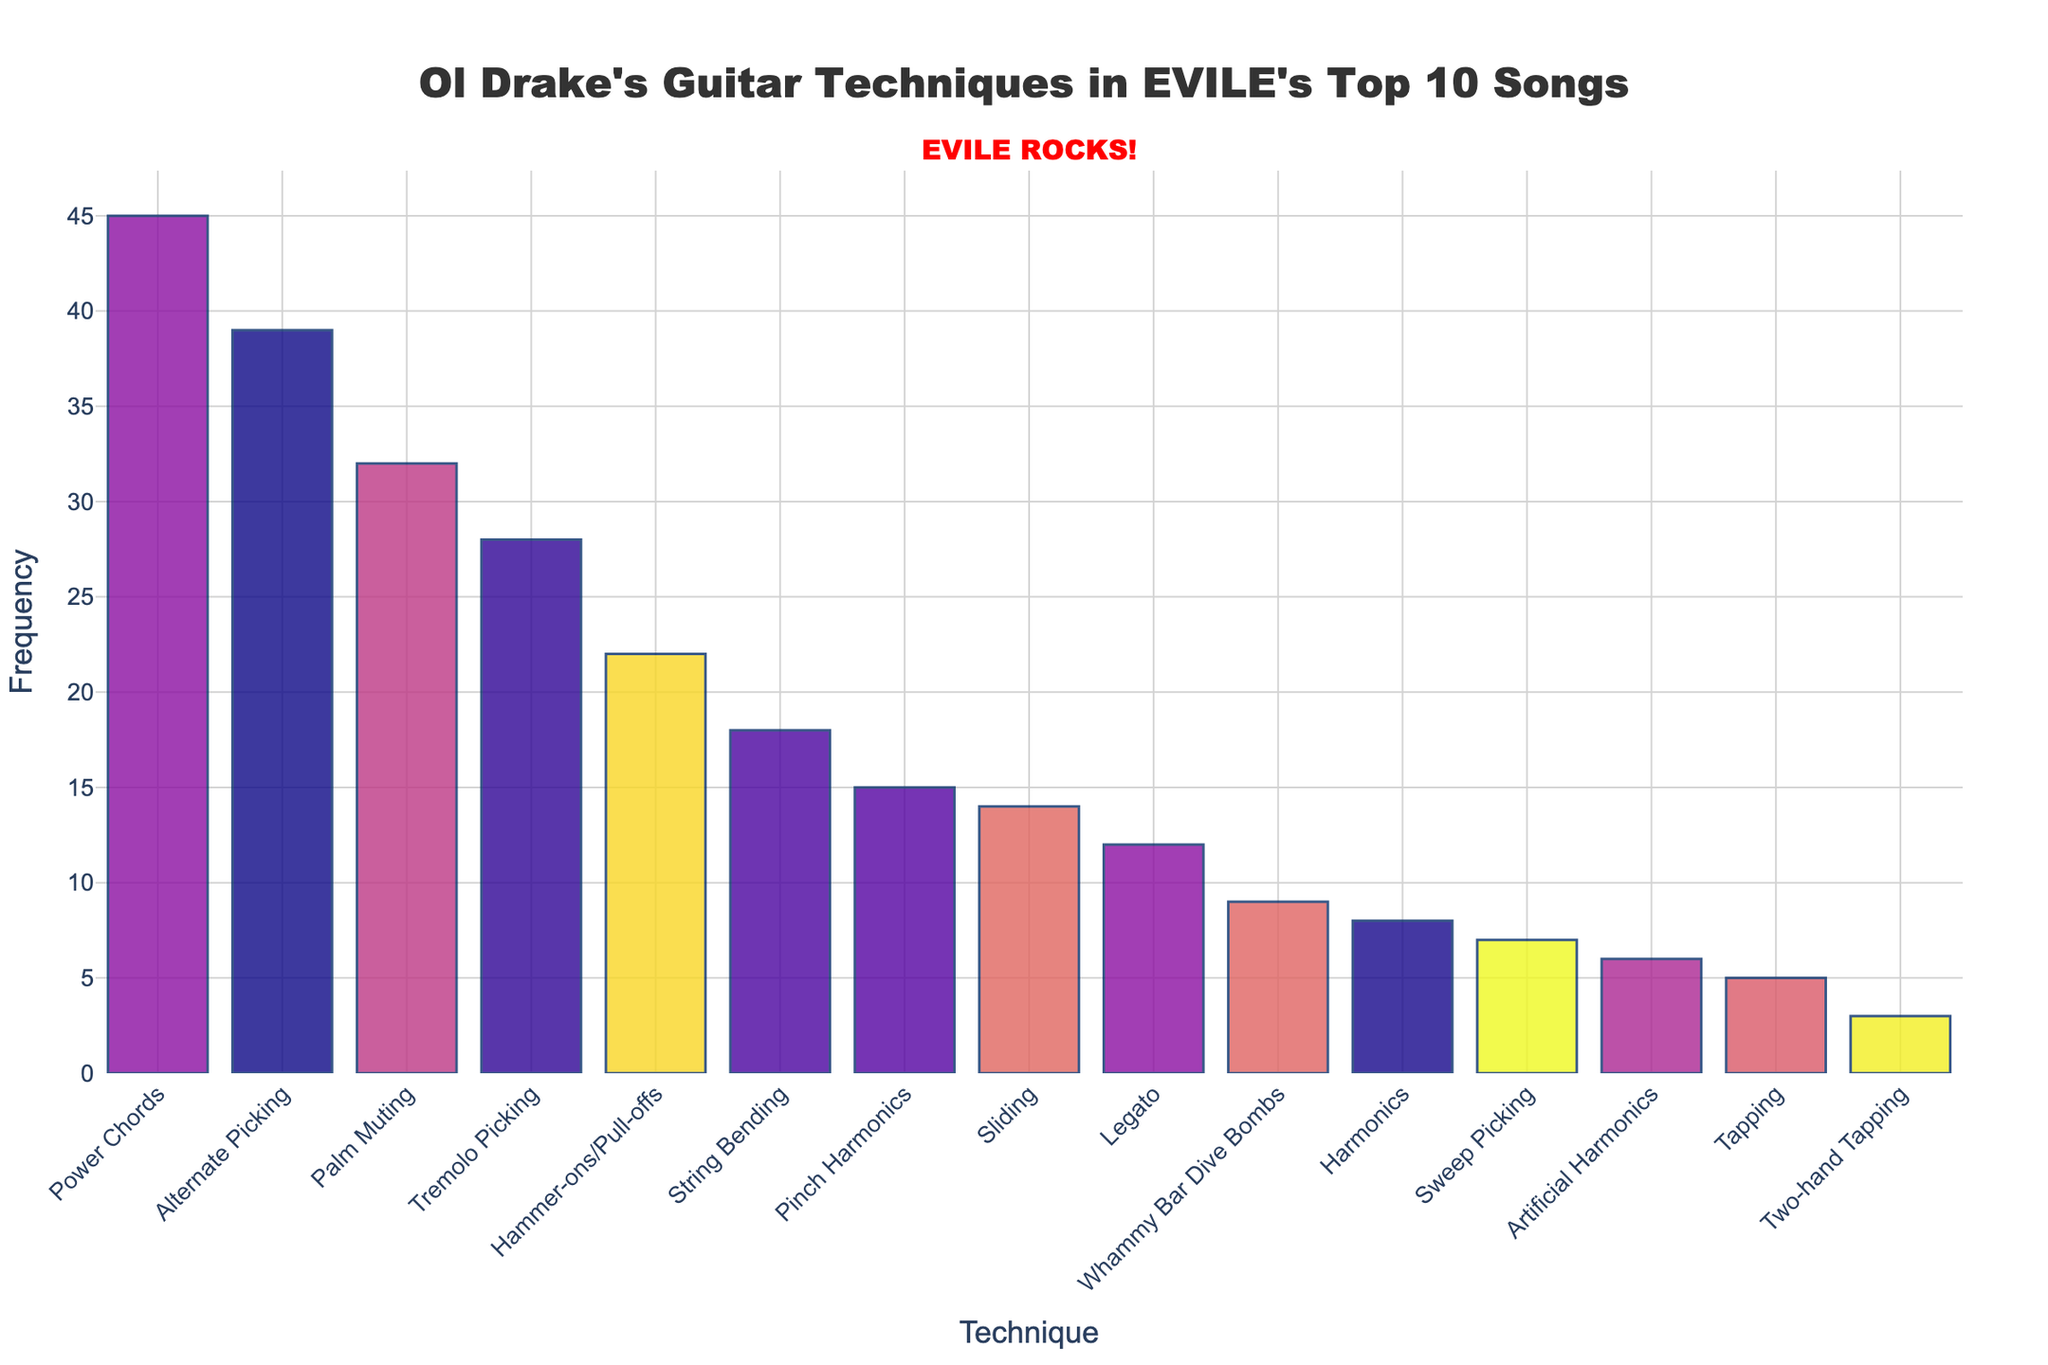What's the most frequently used guitar technique by Ol Drake in EVILE's top 10 most popular songs? To find the most frequently used technique, look for the technique with the highest bar on the chart. The highest bar corresponds to Power Chords with a frequency of 45.
Answer: Power Chords Which technique is used more frequently: Tremolo Picking or String Bending? Compare the heights of the bars for Tremolo Picking and String Bending. Tremolo Picking has a frequency of 28, while String Bending has a frequency of 18.
Answer: Tremolo Picking Calculate the total frequency of Palm Muting and Alternate Picking together. Add the frequencies of Palm Muting and Alternate Picking. Palm Muting has a frequency of 32, and Alternate Picking has a frequency of 39. Therefore, the total is 32 + 39 = 71.
Answer: 71 How many techniques have a frequency of 10 or more? Count the number of techniques with bars reaching 10 or more. From the chart, Palm Muting, Tremolo Picking, Power Chords, Pinch Harmonics, Alternate Picking, Hammer-ons/Pull-offs, String Bending, Whammy Bar Dive Bombs, and Legato qualify.
Answer: 9 What is the least frequently used guitar technique by Ol Drake in the top 10 songs? Identify the bar with the smallest height. Two-hand Tapping has the lowest frequency with a count of 3.
Answer: Two-hand Tapping Which technique shows the closest frequency to Hammer-ons/Pull-offs, excluding Hammer-ons/Pull-offs itself? Compare frequencies of all techniques close to Hammer-ons/Pull-offs (22). String Bending (18) is the closest.
Answer: String Bending Determine the difference in frequency between Power Chords and Artificial Harmonics. Subtract the frequency of Artificial Harmonics (6) from the frequency of Power Chords (45). The difference is 45 - 6 = 39.
Answer: 39 What's the average frequency of Tapping, Sweep Picking, and Harmonics? Add the frequencies of Tapping (5), Sweep Picking (7), and Harmonics (8). The sum is 5 + 7 + 8 = 20. Divide by the number of techniques (3). The average is 20 / 3 ≈ 6.67.
Answer: 6.67 